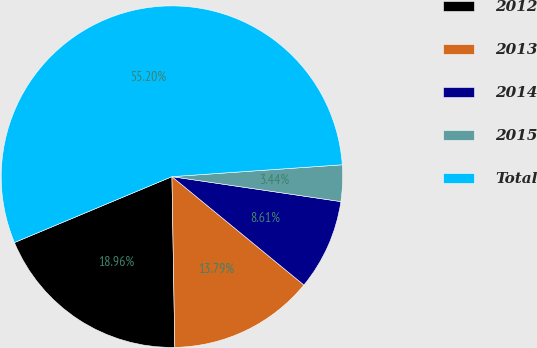<chart> <loc_0><loc_0><loc_500><loc_500><pie_chart><fcel>2012<fcel>2013<fcel>2014<fcel>2015<fcel>Total<nl><fcel>18.96%<fcel>13.79%<fcel>8.61%<fcel>3.44%<fcel>55.2%<nl></chart> 